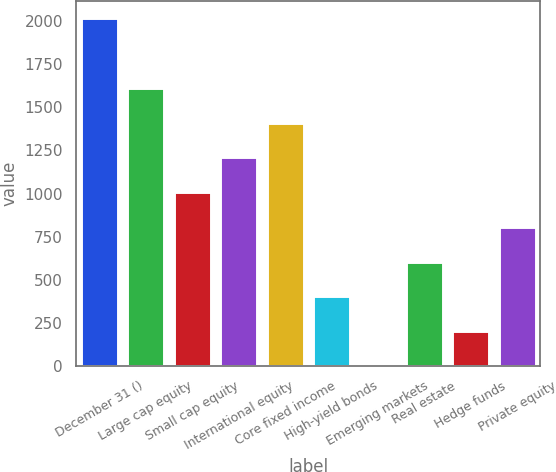Convert chart. <chart><loc_0><loc_0><loc_500><loc_500><bar_chart><fcel>December 31 ()<fcel>Large cap equity<fcel>Small cap equity<fcel>International equity<fcel>Core fixed income<fcel>High-yield bonds<fcel>Emerging markets<fcel>Real estate<fcel>Hedge funds<fcel>Private equity<nl><fcel>2015<fcel>1612.4<fcel>1008.5<fcel>1209.8<fcel>1411.1<fcel>404.6<fcel>2<fcel>605.9<fcel>203.3<fcel>807.2<nl></chart> 